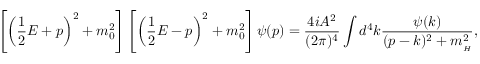Convert formula to latex. <formula><loc_0><loc_0><loc_500><loc_500>\left [ \left ( \frac { 1 } { 2 } E + p \right ) ^ { 2 } + m _ { 0 } ^ { 2 } \right ] \left [ \left ( \frac { 1 } { 2 } E - p \right ) ^ { 2 } + m _ { 0 } ^ { 2 } \right ] \psi ( p ) = \frac { 4 i A ^ { 2 } } { ( 2 \pi ) ^ { 4 } } \int d ^ { 4 } k \frac { \psi ( k ) } { ( p - k ) ^ { 2 } + m _ { _ { H } } ^ { 2 } } ,</formula> 